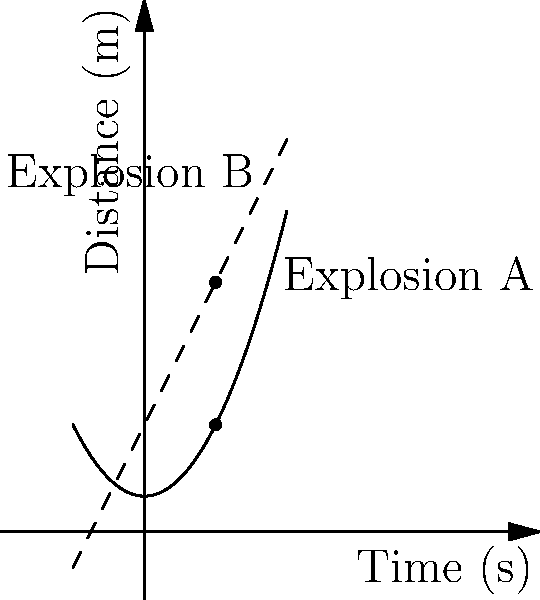In an action sequence, two explosions (A and B) are planned. Explosion A follows a quadratic path described by the function $f(t) = 0.5t^2 + 1$, where $t$ is time in seconds and $f(t)$ is distance in meters. Explosion B follows a linear path described by $g(t) = 2t + 3$. At what time do these explosions occur at the same distance, and what is that distance? To solve this problem, we need to find the intersection point of the two functions:

1) Set the functions equal to each other:
   $0.5t^2 + 1 = 2t + 3$

2) Rearrange the equation:
   $0.5t^2 - 2t - 2 = 0$

3) This is a quadratic equation. We can solve it using the quadratic formula:
   $t = \frac{-b \pm \sqrt{b^2 - 4ac}}{2a}$

   Where $a = 0.5$, $b = -2$, and $c = -2$

4) Plugging in these values:
   $t = \frac{2 \pm \sqrt{(-2)^2 - 4(0.5)(-2)}}{2(0.5)}$
   $= \frac{2 \pm \sqrt{4 + 4}}{1}$
   $= 2 \pm \sqrt{8}$
   $= 2 \pm 2\sqrt{2}$

5) This gives us two solutions: $2 + 2\sqrt{2}$ and $2 - 2\sqrt{2}$. Since time can't be negative in this context, we take the positive solution:
   $t = 2 + 2\sqrt{2} \approx 4.83$ seconds

6) To find the distance, we can plug this time back into either function. Let's use $f(t)$:
   $f(4.83) = 0.5(4.83)^2 + 1 \approx 12.66$ meters

Therefore, the explosions occur at the same distance after approximately 4.83 seconds, at a distance of about 12.66 meters.
Answer: $t \approx 4.83$ seconds, distance $\approx 12.66$ meters 